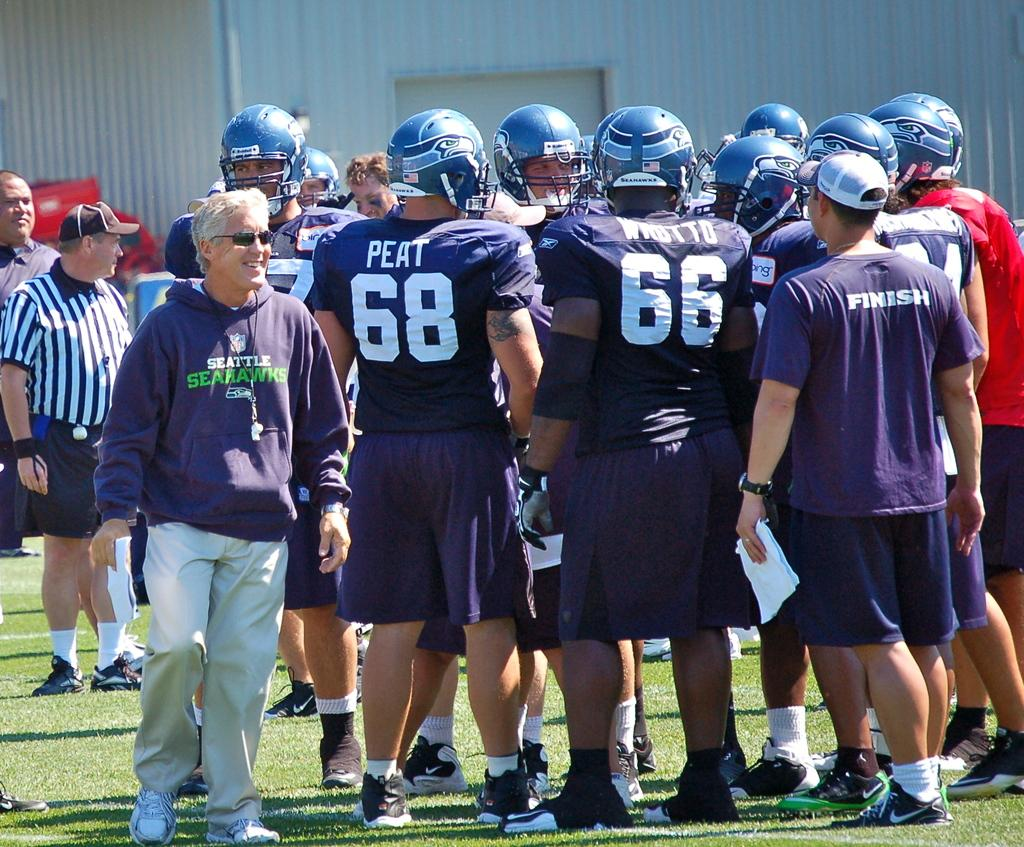How many people are in the group that is visible in the image? There is a group of people in the image. What are some of the people in the group wearing? Some people in the group are wearing helmets, while others are wearing capes. What is the surface that the people are standing on? The people are standing on the grass. What type of owl can be seen flying over the group of people in the image? There is no owl present in the image; it only features a group of people standing on the grass. How does the ink affect the group of people in the image? There is no ink present in the image, so it cannot affect the group of people. 